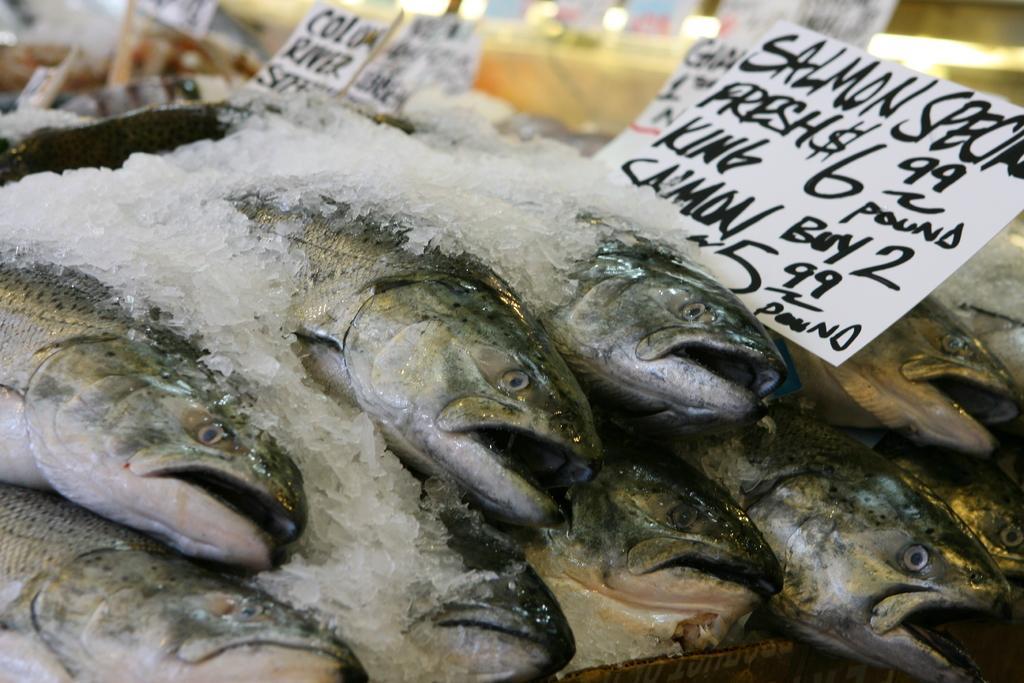Please provide a concise description of this image. In the center of the image we can see fish with some ice on it. And we can see the papers with some text and price. In the background, we can see the lights and a few other objects. 